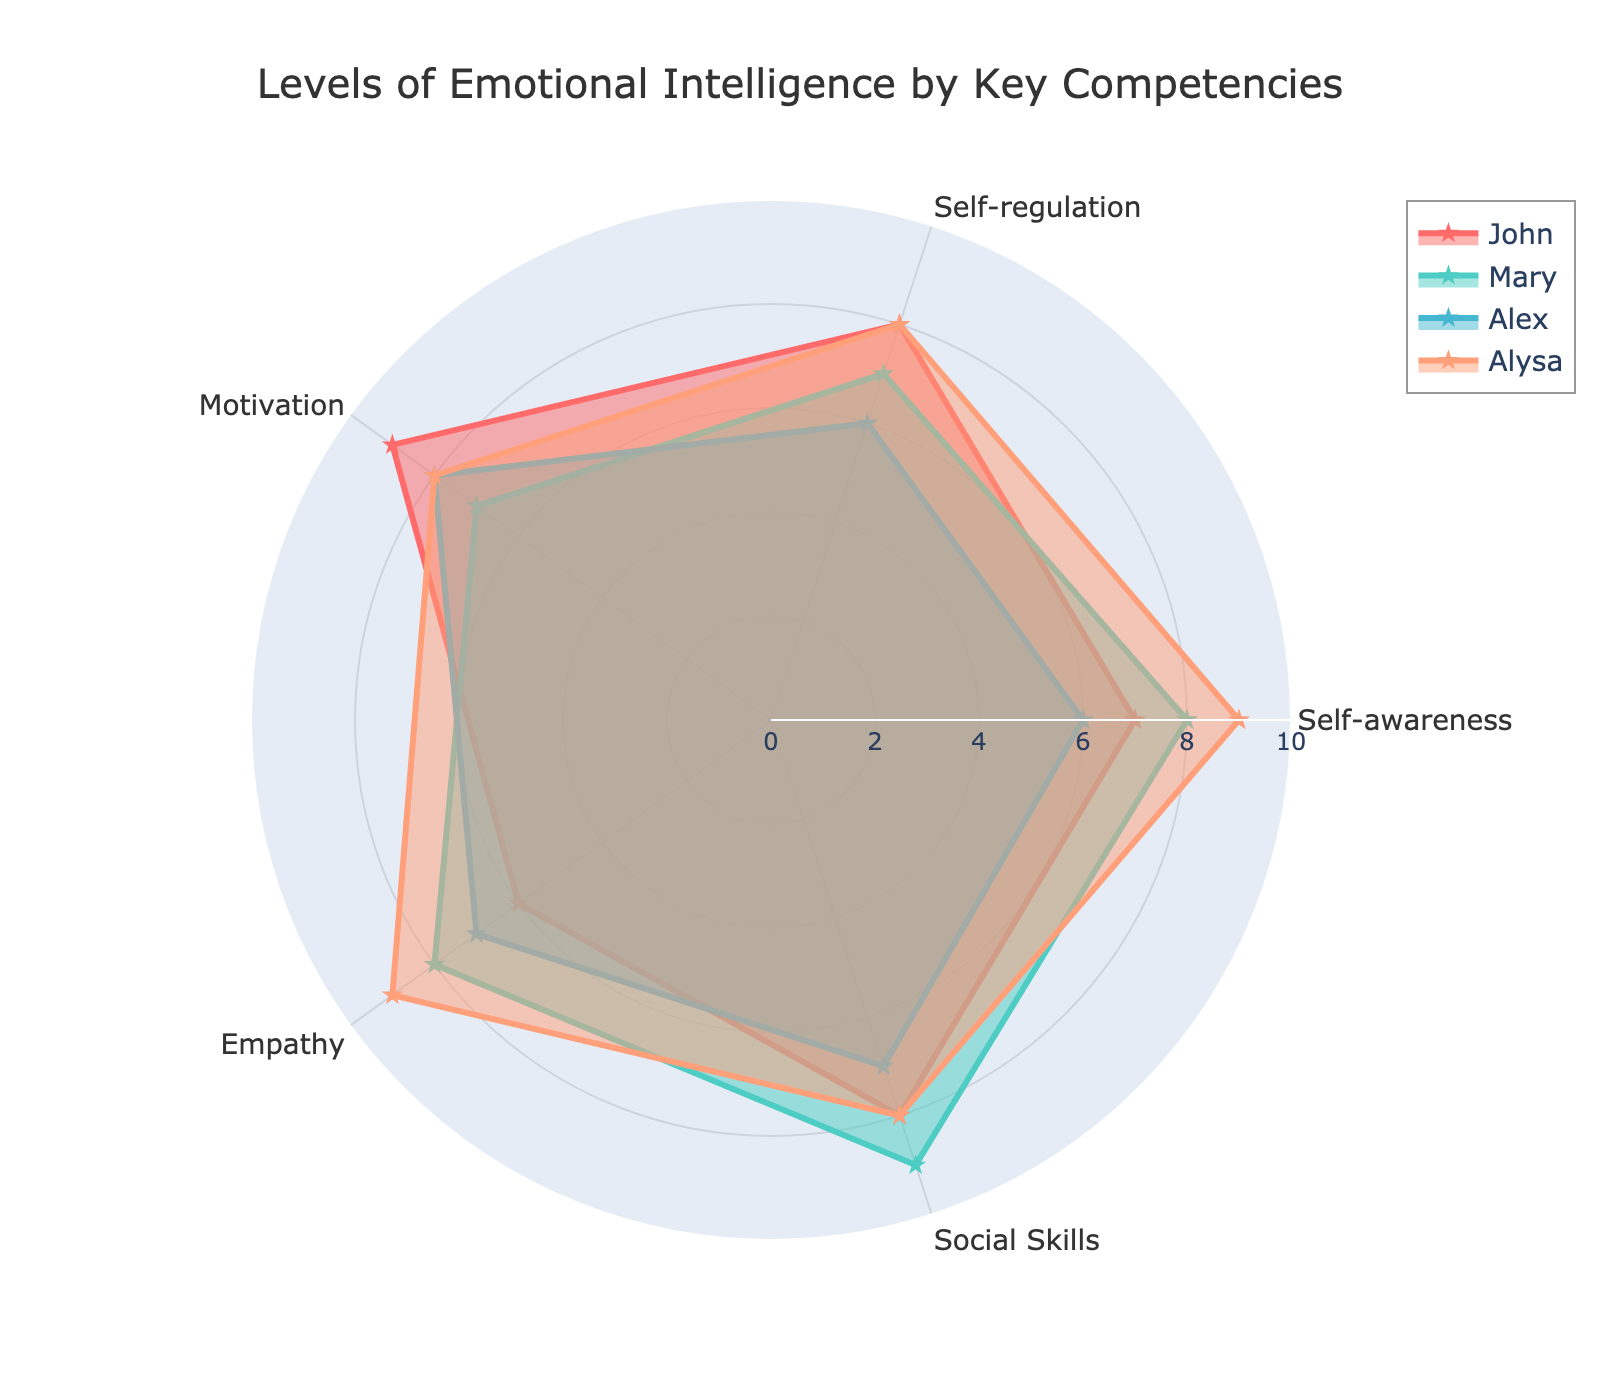What is the title of the radar chart? The title is found at the top of the radar chart, indicating what the chart represents. In this case, the title is 'Levels of Emotional Intelligence by Key Competencies.'
Answer: Levels of Emotional Intelligence by Key Competencies How many key competencies are represented in the radar chart? By counting the different categories (sometimes positioned at angular locations), we see there are five key competencies listed around the radar chart.
Answer: Five Which competency does Alysa score the highest in? To determine this, we compare Alysa's values across all competencies: Self-awareness (9), Self-regulation (8), Motivation (8), Empathy (9), Social Skills (8). The highest score is 9 in both Self-awareness and Empathy.
Answer: Self-awareness and Empathy Who has the highest score in Social Skills? We need to look at the values for Social Skills across all individuals: John (8), Mary (9), Alex (7), and Alysa (8). Mary has the highest score of 9.
Answer: Mary What is the average score of Alex across all the competencies? Alex's scores are: Self-awareness (6), Self-regulation (6), Motivation (8), Empathy (7), Social Skills (7). Sum these up: 6 + 6 + 8 + 7 + 7 = 34. Then divide by the number of competencies, 34/5 = 6.8.
Answer: 6.8 